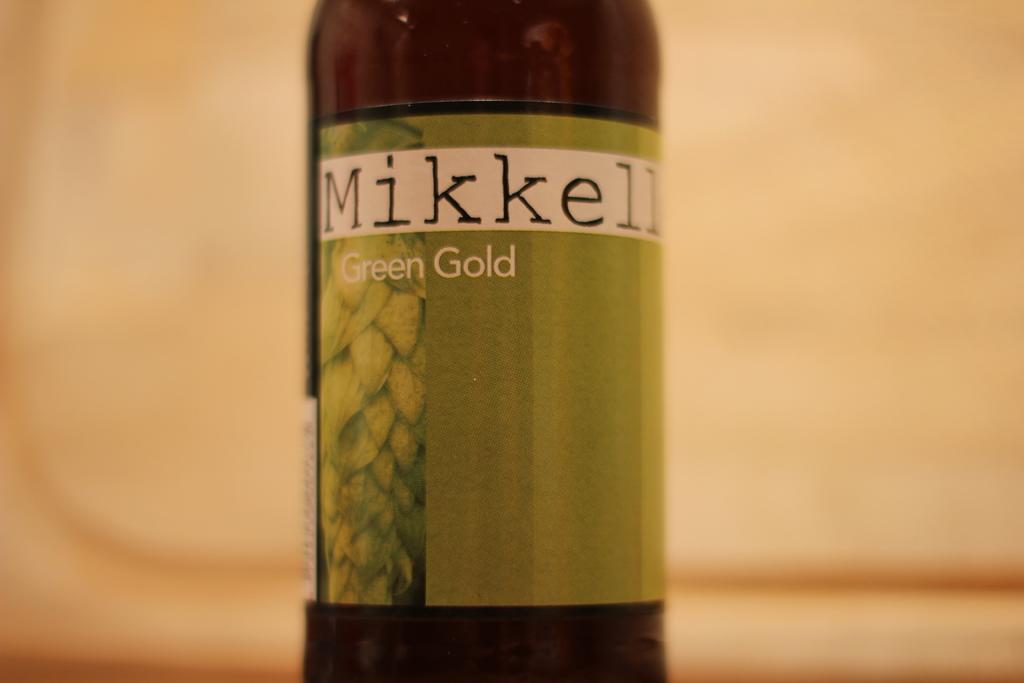What is the bottle?
Your response must be concise. Mikkell green gold. What color is advertised?
Offer a terse response. Green gold. 